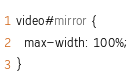Convert code to text. <code><loc_0><loc_0><loc_500><loc_500><_CSS_>video#mirror {
  max-width: 100%;
}

</code> 